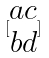<formula> <loc_0><loc_0><loc_500><loc_500>[ \begin{matrix} a c \\ b d \end{matrix} ]</formula> 